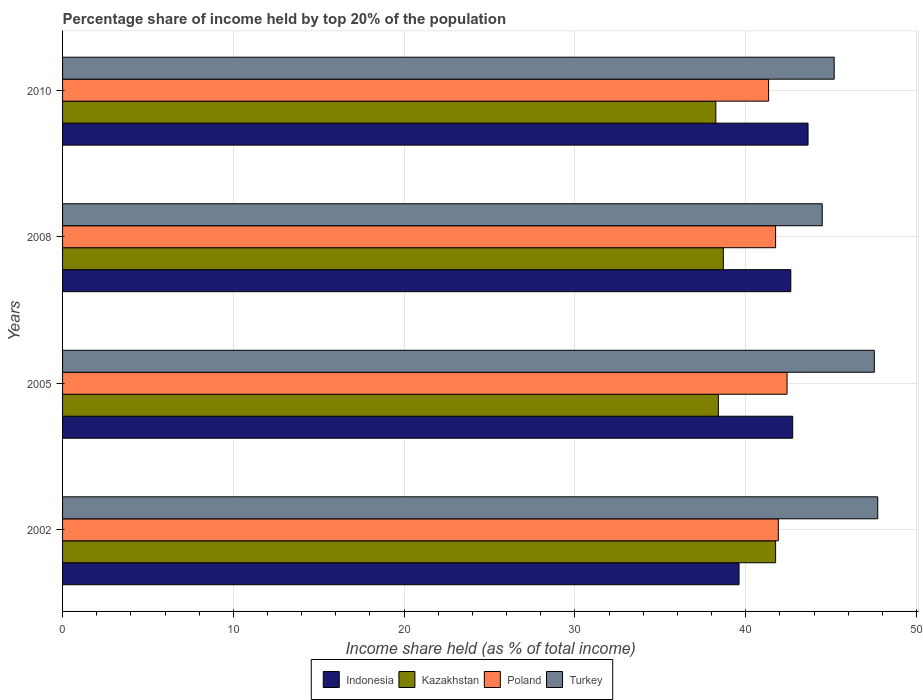How many different coloured bars are there?
Provide a succinct answer. 4. Are the number of bars per tick equal to the number of legend labels?
Offer a terse response. Yes. Are the number of bars on each tick of the Y-axis equal?
Offer a terse response. Yes. How many bars are there on the 3rd tick from the top?
Give a very brief answer. 4. How many bars are there on the 2nd tick from the bottom?
Make the answer very short. 4. What is the label of the 3rd group of bars from the top?
Provide a succinct answer. 2005. What is the percentage share of income held by top 20% of the population in Indonesia in 2002?
Keep it short and to the point. 39.61. Across all years, what is the maximum percentage share of income held by top 20% of the population in Indonesia?
Provide a succinct answer. 43.65. Across all years, what is the minimum percentage share of income held by top 20% of the population in Kazakhstan?
Your answer should be compact. 38.25. In which year was the percentage share of income held by top 20% of the population in Kazakhstan minimum?
Offer a terse response. 2010. What is the total percentage share of income held by top 20% of the population in Indonesia in the graph?
Your answer should be very brief. 168.65. What is the difference between the percentage share of income held by top 20% of the population in Turkey in 2002 and that in 2005?
Your answer should be very brief. 0.2. What is the difference between the percentage share of income held by top 20% of the population in Indonesia in 2005 and the percentage share of income held by top 20% of the population in Turkey in 2008?
Provide a succinct answer. -1.73. What is the average percentage share of income held by top 20% of the population in Indonesia per year?
Your answer should be very brief. 42.16. In the year 2005, what is the difference between the percentage share of income held by top 20% of the population in Indonesia and percentage share of income held by top 20% of the population in Kazakhstan?
Make the answer very short. 4.35. In how many years, is the percentage share of income held by top 20% of the population in Turkey greater than 36 %?
Keep it short and to the point. 4. What is the ratio of the percentage share of income held by top 20% of the population in Indonesia in 2002 to that in 2008?
Provide a succinct answer. 0.93. Is the percentage share of income held by top 20% of the population in Kazakhstan in 2005 less than that in 2010?
Provide a short and direct response. No. Is the difference between the percentage share of income held by top 20% of the population in Indonesia in 2008 and 2010 greater than the difference between the percentage share of income held by top 20% of the population in Kazakhstan in 2008 and 2010?
Make the answer very short. No. What is the difference between the highest and the second highest percentage share of income held by top 20% of the population in Indonesia?
Your answer should be very brief. 0.9. In how many years, is the percentage share of income held by top 20% of the population in Indonesia greater than the average percentage share of income held by top 20% of the population in Indonesia taken over all years?
Your answer should be very brief. 3. Is the sum of the percentage share of income held by top 20% of the population in Kazakhstan in 2002 and 2005 greater than the maximum percentage share of income held by top 20% of the population in Poland across all years?
Provide a short and direct response. Yes. What does the 3rd bar from the top in 2008 represents?
Ensure brevity in your answer.  Kazakhstan. What does the 2nd bar from the bottom in 2005 represents?
Your answer should be very brief. Kazakhstan. Is it the case that in every year, the sum of the percentage share of income held by top 20% of the population in Kazakhstan and percentage share of income held by top 20% of the population in Turkey is greater than the percentage share of income held by top 20% of the population in Indonesia?
Provide a short and direct response. Yes. How many bars are there?
Your answer should be compact. 16. Are all the bars in the graph horizontal?
Offer a very short reply. Yes. What is the difference between two consecutive major ticks on the X-axis?
Your response must be concise. 10. Does the graph contain any zero values?
Provide a succinct answer. No. Where does the legend appear in the graph?
Your answer should be compact. Bottom center. How are the legend labels stacked?
Provide a short and direct response. Horizontal. What is the title of the graph?
Provide a succinct answer. Percentage share of income held by top 20% of the population. Does "Jamaica" appear as one of the legend labels in the graph?
Keep it short and to the point. No. What is the label or title of the X-axis?
Ensure brevity in your answer.  Income share held (as % of total income). What is the Income share held (as % of total income) of Indonesia in 2002?
Make the answer very short. 39.61. What is the Income share held (as % of total income) in Kazakhstan in 2002?
Offer a very short reply. 41.75. What is the Income share held (as % of total income) of Poland in 2002?
Your response must be concise. 41.91. What is the Income share held (as % of total income) in Turkey in 2002?
Provide a short and direct response. 47.73. What is the Income share held (as % of total income) of Indonesia in 2005?
Your answer should be compact. 42.75. What is the Income share held (as % of total income) of Kazakhstan in 2005?
Keep it short and to the point. 38.4. What is the Income share held (as % of total income) in Poland in 2005?
Provide a short and direct response. 42.42. What is the Income share held (as % of total income) of Turkey in 2005?
Make the answer very short. 47.53. What is the Income share held (as % of total income) of Indonesia in 2008?
Offer a very short reply. 42.64. What is the Income share held (as % of total income) of Kazakhstan in 2008?
Ensure brevity in your answer.  38.69. What is the Income share held (as % of total income) of Poland in 2008?
Provide a succinct answer. 41.75. What is the Income share held (as % of total income) in Turkey in 2008?
Offer a very short reply. 44.48. What is the Income share held (as % of total income) of Indonesia in 2010?
Make the answer very short. 43.65. What is the Income share held (as % of total income) in Kazakhstan in 2010?
Give a very brief answer. 38.25. What is the Income share held (as % of total income) in Poland in 2010?
Offer a very short reply. 41.34. What is the Income share held (as % of total income) of Turkey in 2010?
Your response must be concise. 45.18. Across all years, what is the maximum Income share held (as % of total income) of Indonesia?
Your response must be concise. 43.65. Across all years, what is the maximum Income share held (as % of total income) of Kazakhstan?
Ensure brevity in your answer.  41.75. Across all years, what is the maximum Income share held (as % of total income) of Poland?
Your answer should be very brief. 42.42. Across all years, what is the maximum Income share held (as % of total income) of Turkey?
Ensure brevity in your answer.  47.73. Across all years, what is the minimum Income share held (as % of total income) of Indonesia?
Keep it short and to the point. 39.61. Across all years, what is the minimum Income share held (as % of total income) in Kazakhstan?
Provide a short and direct response. 38.25. Across all years, what is the minimum Income share held (as % of total income) in Poland?
Provide a succinct answer. 41.34. Across all years, what is the minimum Income share held (as % of total income) in Turkey?
Give a very brief answer. 44.48. What is the total Income share held (as % of total income) in Indonesia in the graph?
Keep it short and to the point. 168.65. What is the total Income share held (as % of total income) of Kazakhstan in the graph?
Offer a very short reply. 157.09. What is the total Income share held (as % of total income) of Poland in the graph?
Offer a terse response. 167.42. What is the total Income share held (as % of total income) of Turkey in the graph?
Give a very brief answer. 184.92. What is the difference between the Income share held (as % of total income) in Indonesia in 2002 and that in 2005?
Ensure brevity in your answer.  -3.14. What is the difference between the Income share held (as % of total income) of Kazakhstan in 2002 and that in 2005?
Provide a succinct answer. 3.35. What is the difference between the Income share held (as % of total income) of Poland in 2002 and that in 2005?
Ensure brevity in your answer.  -0.51. What is the difference between the Income share held (as % of total income) of Turkey in 2002 and that in 2005?
Your answer should be very brief. 0.2. What is the difference between the Income share held (as % of total income) of Indonesia in 2002 and that in 2008?
Your response must be concise. -3.03. What is the difference between the Income share held (as % of total income) of Kazakhstan in 2002 and that in 2008?
Offer a terse response. 3.06. What is the difference between the Income share held (as % of total income) in Poland in 2002 and that in 2008?
Offer a terse response. 0.16. What is the difference between the Income share held (as % of total income) of Indonesia in 2002 and that in 2010?
Provide a succinct answer. -4.04. What is the difference between the Income share held (as % of total income) in Kazakhstan in 2002 and that in 2010?
Ensure brevity in your answer.  3.5. What is the difference between the Income share held (as % of total income) of Poland in 2002 and that in 2010?
Your answer should be compact. 0.57. What is the difference between the Income share held (as % of total income) in Turkey in 2002 and that in 2010?
Provide a short and direct response. 2.55. What is the difference between the Income share held (as % of total income) in Indonesia in 2005 and that in 2008?
Offer a very short reply. 0.11. What is the difference between the Income share held (as % of total income) in Kazakhstan in 2005 and that in 2008?
Your answer should be compact. -0.29. What is the difference between the Income share held (as % of total income) of Poland in 2005 and that in 2008?
Your response must be concise. 0.67. What is the difference between the Income share held (as % of total income) in Turkey in 2005 and that in 2008?
Your answer should be very brief. 3.05. What is the difference between the Income share held (as % of total income) of Indonesia in 2005 and that in 2010?
Offer a terse response. -0.9. What is the difference between the Income share held (as % of total income) in Kazakhstan in 2005 and that in 2010?
Give a very brief answer. 0.15. What is the difference between the Income share held (as % of total income) of Poland in 2005 and that in 2010?
Keep it short and to the point. 1.08. What is the difference between the Income share held (as % of total income) in Turkey in 2005 and that in 2010?
Your answer should be compact. 2.35. What is the difference between the Income share held (as % of total income) in Indonesia in 2008 and that in 2010?
Your response must be concise. -1.01. What is the difference between the Income share held (as % of total income) of Kazakhstan in 2008 and that in 2010?
Your response must be concise. 0.44. What is the difference between the Income share held (as % of total income) in Poland in 2008 and that in 2010?
Offer a very short reply. 0.41. What is the difference between the Income share held (as % of total income) of Turkey in 2008 and that in 2010?
Make the answer very short. -0.7. What is the difference between the Income share held (as % of total income) of Indonesia in 2002 and the Income share held (as % of total income) of Kazakhstan in 2005?
Give a very brief answer. 1.21. What is the difference between the Income share held (as % of total income) of Indonesia in 2002 and the Income share held (as % of total income) of Poland in 2005?
Make the answer very short. -2.81. What is the difference between the Income share held (as % of total income) of Indonesia in 2002 and the Income share held (as % of total income) of Turkey in 2005?
Provide a succinct answer. -7.92. What is the difference between the Income share held (as % of total income) of Kazakhstan in 2002 and the Income share held (as % of total income) of Poland in 2005?
Your answer should be very brief. -0.67. What is the difference between the Income share held (as % of total income) in Kazakhstan in 2002 and the Income share held (as % of total income) in Turkey in 2005?
Give a very brief answer. -5.78. What is the difference between the Income share held (as % of total income) in Poland in 2002 and the Income share held (as % of total income) in Turkey in 2005?
Give a very brief answer. -5.62. What is the difference between the Income share held (as % of total income) of Indonesia in 2002 and the Income share held (as % of total income) of Kazakhstan in 2008?
Your answer should be compact. 0.92. What is the difference between the Income share held (as % of total income) of Indonesia in 2002 and the Income share held (as % of total income) of Poland in 2008?
Offer a terse response. -2.14. What is the difference between the Income share held (as % of total income) of Indonesia in 2002 and the Income share held (as % of total income) of Turkey in 2008?
Ensure brevity in your answer.  -4.87. What is the difference between the Income share held (as % of total income) in Kazakhstan in 2002 and the Income share held (as % of total income) in Poland in 2008?
Your answer should be very brief. 0. What is the difference between the Income share held (as % of total income) in Kazakhstan in 2002 and the Income share held (as % of total income) in Turkey in 2008?
Your answer should be very brief. -2.73. What is the difference between the Income share held (as % of total income) in Poland in 2002 and the Income share held (as % of total income) in Turkey in 2008?
Keep it short and to the point. -2.57. What is the difference between the Income share held (as % of total income) in Indonesia in 2002 and the Income share held (as % of total income) in Kazakhstan in 2010?
Give a very brief answer. 1.36. What is the difference between the Income share held (as % of total income) of Indonesia in 2002 and the Income share held (as % of total income) of Poland in 2010?
Make the answer very short. -1.73. What is the difference between the Income share held (as % of total income) of Indonesia in 2002 and the Income share held (as % of total income) of Turkey in 2010?
Provide a short and direct response. -5.57. What is the difference between the Income share held (as % of total income) in Kazakhstan in 2002 and the Income share held (as % of total income) in Poland in 2010?
Your answer should be very brief. 0.41. What is the difference between the Income share held (as % of total income) of Kazakhstan in 2002 and the Income share held (as % of total income) of Turkey in 2010?
Offer a very short reply. -3.43. What is the difference between the Income share held (as % of total income) in Poland in 2002 and the Income share held (as % of total income) in Turkey in 2010?
Offer a terse response. -3.27. What is the difference between the Income share held (as % of total income) in Indonesia in 2005 and the Income share held (as % of total income) in Kazakhstan in 2008?
Your answer should be very brief. 4.06. What is the difference between the Income share held (as % of total income) of Indonesia in 2005 and the Income share held (as % of total income) of Poland in 2008?
Give a very brief answer. 1. What is the difference between the Income share held (as % of total income) of Indonesia in 2005 and the Income share held (as % of total income) of Turkey in 2008?
Give a very brief answer. -1.73. What is the difference between the Income share held (as % of total income) in Kazakhstan in 2005 and the Income share held (as % of total income) in Poland in 2008?
Provide a short and direct response. -3.35. What is the difference between the Income share held (as % of total income) in Kazakhstan in 2005 and the Income share held (as % of total income) in Turkey in 2008?
Your response must be concise. -6.08. What is the difference between the Income share held (as % of total income) in Poland in 2005 and the Income share held (as % of total income) in Turkey in 2008?
Offer a very short reply. -2.06. What is the difference between the Income share held (as % of total income) in Indonesia in 2005 and the Income share held (as % of total income) in Kazakhstan in 2010?
Your answer should be very brief. 4.5. What is the difference between the Income share held (as % of total income) of Indonesia in 2005 and the Income share held (as % of total income) of Poland in 2010?
Provide a short and direct response. 1.41. What is the difference between the Income share held (as % of total income) in Indonesia in 2005 and the Income share held (as % of total income) in Turkey in 2010?
Your answer should be compact. -2.43. What is the difference between the Income share held (as % of total income) in Kazakhstan in 2005 and the Income share held (as % of total income) in Poland in 2010?
Your answer should be compact. -2.94. What is the difference between the Income share held (as % of total income) of Kazakhstan in 2005 and the Income share held (as % of total income) of Turkey in 2010?
Provide a succinct answer. -6.78. What is the difference between the Income share held (as % of total income) of Poland in 2005 and the Income share held (as % of total income) of Turkey in 2010?
Give a very brief answer. -2.76. What is the difference between the Income share held (as % of total income) of Indonesia in 2008 and the Income share held (as % of total income) of Kazakhstan in 2010?
Give a very brief answer. 4.39. What is the difference between the Income share held (as % of total income) of Indonesia in 2008 and the Income share held (as % of total income) of Poland in 2010?
Offer a very short reply. 1.3. What is the difference between the Income share held (as % of total income) in Indonesia in 2008 and the Income share held (as % of total income) in Turkey in 2010?
Your answer should be very brief. -2.54. What is the difference between the Income share held (as % of total income) in Kazakhstan in 2008 and the Income share held (as % of total income) in Poland in 2010?
Keep it short and to the point. -2.65. What is the difference between the Income share held (as % of total income) of Kazakhstan in 2008 and the Income share held (as % of total income) of Turkey in 2010?
Give a very brief answer. -6.49. What is the difference between the Income share held (as % of total income) in Poland in 2008 and the Income share held (as % of total income) in Turkey in 2010?
Provide a short and direct response. -3.43. What is the average Income share held (as % of total income) of Indonesia per year?
Offer a very short reply. 42.16. What is the average Income share held (as % of total income) in Kazakhstan per year?
Provide a succinct answer. 39.27. What is the average Income share held (as % of total income) of Poland per year?
Your response must be concise. 41.85. What is the average Income share held (as % of total income) of Turkey per year?
Ensure brevity in your answer.  46.23. In the year 2002, what is the difference between the Income share held (as % of total income) in Indonesia and Income share held (as % of total income) in Kazakhstan?
Your response must be concise. -2.14. In the year 2002, what is the difference between the Income share held (as % of total income) in Indonesia and Income share held (as % of total income) in Poland?
Keep it short and to the point. -2.3. In the year 2002, what is the difference between the Income share held (as % of total income) in Indonesia and Income share held (as % of total income) in Turkey?
Your answer should be compact. -8.12. In the year 2002, what is the difference between the Income share held (as % of total income) of Kazakhstan and Income share held (as % of total income) of Poland?
Make the answer very short. -0.16. In the year 2002, what is the difference between the Income share held (as % of total income) of Kazakhstan and Income share held (as % of total income) of Turkey?
Provide a succinct answer. -5.98. In the year 2002, what is the difference between the Income share held (as % of total income) in Poland and Income share held (as % of total income) in Turkey?
Make the answer very short. -5.82. In the year 2005, what is the difference between the Income share held (as % of total income) in Indonesia and Income share held (as % of total income) in Kazakhstan?
Offer a terse response. 4.35. In the year 2005, what is the difference between the Income share held (as % of total income) of Indonesia and Income share held (as % of total income) of Poland?
Provide a succinct answer. 0.33. In the year 2005, what is the difference between the Income share held (as % of total income) of Indonesia and Income share held (as % of total income) of Turkey?
Provide a short and direct response. -4.78. In the year 2005, what is the difference between the Income share held (as % of total income) of Kazakhstan and Income share held (as % of total income) of Poland?
Your answer should be compact. -4.02. In the year 2005, what is the difference between the Income share held (as % of total income) of Kazakhstan and Income share held (as % of total income) of Turkey?
Make the answer very short. -9.13. In the year 2005, what is the difference between the Income share held (as % of total income) of Poland and Income share held (as % of total income) of Turkey?
Your answer should be very brief. -5.11. In the year 2008, what is the difference between the Income share held (as % of total income) in Indonesia and Income share held (as % of total income) in Kazakhstan?
Your response must be concise. 3.95. In the year 2008, what is the difference between the Income share held (as % of total income) in Indonesia and Income share held (as % of total income) in Poland?
Give a very brief answer. 0.89. In the year 2008, what is the difference between the Income share held (as % of total income) of Indonesia and Income share held (as % of total income) of Turkey?
Offer a very short reply. -1.84. In the year 2008, what is the difference between the Income share held (as % of total income) in Kazakhstan and Income share held (as % of total income) in Poland?
Offer a very short reply. -3.06. In the year 2008, what is the difference between the Income share held (as % of total income) of Kazakhstan and Income share held (as % of total income) of Turkey?
Your response must be concise. -5.79. In the year 2008, what is the difference between the Income share held (as % of total income) in Poland and Income share held (as % of total income) in Turkey?
Your response must be concise. -2.73. In the year 2010, what is the difference between the Income share held (as % of total income) of Indonesia and Income share held (as % of total income) of Poland?
Ensure brevity in your answer.  2.31. In the year 2010, what is the difference between the Income share held (as % of total income) of Indonesia and Income share held (as % of total income) of Turkey?
Provide a succinct answer. -1.53. In the year 2010, what is the difference between the Income share held (as % of total income) of Kazakhstan and Income share held (as % of total income) of Poland?
Offer a very short reply. -3.09. In the year 2010, what is the difference between the Income share held (as % of total income) of Kazakhstan and Income share held (as % of total income) of Turkey?
Keep it short and to the point. -6.93. In the year 2010, what is the difference between the Income share held (as % of total income) in Poland and Income share held (as % of total income) in Turkey?
Ensure brevity in your answer.  -3.84. What is the ratio of the Income share held (as % of total income) in Indonesia in 2002 to that in 2005?
Your answer should be compact. 0.93. What is the ratio of the Income share held (as % of total income) in Kazakhstan in 2002 to that in 2005?
Your response must be concise. 1.09. What is the ratio of the Income share held (as % of total income) in Poland in 2002 to that in 2005?
Provide a succinct answer. 0.99. What is the ratio of the Income share held (as % of total income) in Indonesia in 2002 to that in 2008?
Provide a succinct answer. 0.93. What is the ratio of the Income share held (as % of total income) of Kazakhstan in 2002 to that in 2008?
Keep it short and to the point. 1.08. What is the ratio of the Income share held (as % of total income) in Poland in 2002 to that in 2008?
Offer a very short reply. 1. What is the ratio of the Income share held (as % of total income) in Turkey in 2002 to that in 2008?
Provide a succinct answer. 1.07. What is the ratio of the Income share held (as % of total income) of Indonesia in 2002 to that in 2010?
Offer a very short reply. 0.91. What is the ratio of the Income share held (as % of total income) of Kazakhstan in 2002 to that in 2010?
Provide a succinct answer. 1.09. What is the ratio of the Income share held (as % of total income) in Poland in 2002 to that in 2010?
Make the answer very short. 1.01. What is the ratio of the Income share held (as % of total income) in Turkey in 2002 to that in 2010?
Make the answer very short. 1.06. What is the ratio of the Income share held (as % of total income) of Indonesia in 2005 to that in 2008?
Provide a short and direct response. 1. What is the ratio of the Income share held (as % of total income) in Kazakhstan in 2005 to that in 2008?
Keep it short and to the point. 0.99. What is the ratio of the Income share held (as % of total income) in Turkey in 2005 to that in 2008?
Give a very brief answer. 1.07. What is the ratio of the Income share held (as % of total income) in Indonesia in 2005 to that in 2010?
Give a very brief answer. 0.98. What is the ratio of the Income share held (as % of total income) in Kazakhstan in 2005 to that in 2010?
Provide a succinct answer. 1. What is the ratio of the Income share held (as % of total income) of Poland in 2005 to that in 2010?
Your response must be concise. 1.03. What is the ratio of the Income share held (as % of total income) of Turkey in 2005 to that in 2010?
Offer a very short reply. 1.05. What is the ratio of the Income share held (as % of total income) of Indonesia in 2008 to that in 2010?
Provide a short and direct response. 0.98. What is the ratio of the Income share held (as % of total income) of Kazakhstan in 2008 to that in 2010?
Keep it short and to the point. 1.01. What is the ratio of the Income share held (as % of total income) of Poland in 2008 to that in 2010?
Offer a very short reply. 1.01. What is the ratio of the Income share held (as % of total income) in Turkey in 2008 to that in 2010?
Your answer should be compact. 0.98. What is the difference between the highest and the second highest Income share held (as % of total income) of Kazakhstan?
Provide a short and direct response. 3.06. What is the difference between the highest and the second highest Income share held (as % of total income) in Poland?
Provide a short and direct response. 0.51. What is the difference between the highest and the lowest Income share held (as % of total income) in Indonesia?
Your response must be concise. 4.04. 